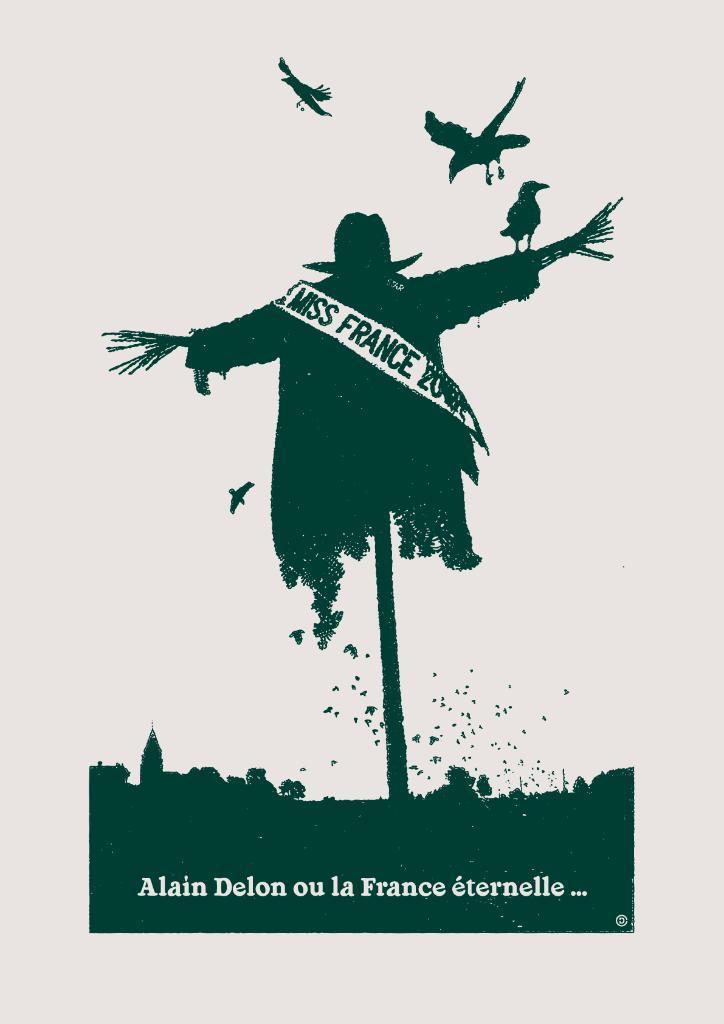In one or two sentences, can you explain what this image depicts? In the picture there is a painting of a person, there are birds present, there is a text on painting. 